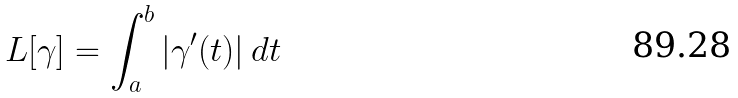<formula> <loc_0><loc_0><loc_500><loc_500>L [ \gamma ] = \int _ { a } ^ { b } | \gamma ^ { \prime } ( t ) | \, d t</formula> 